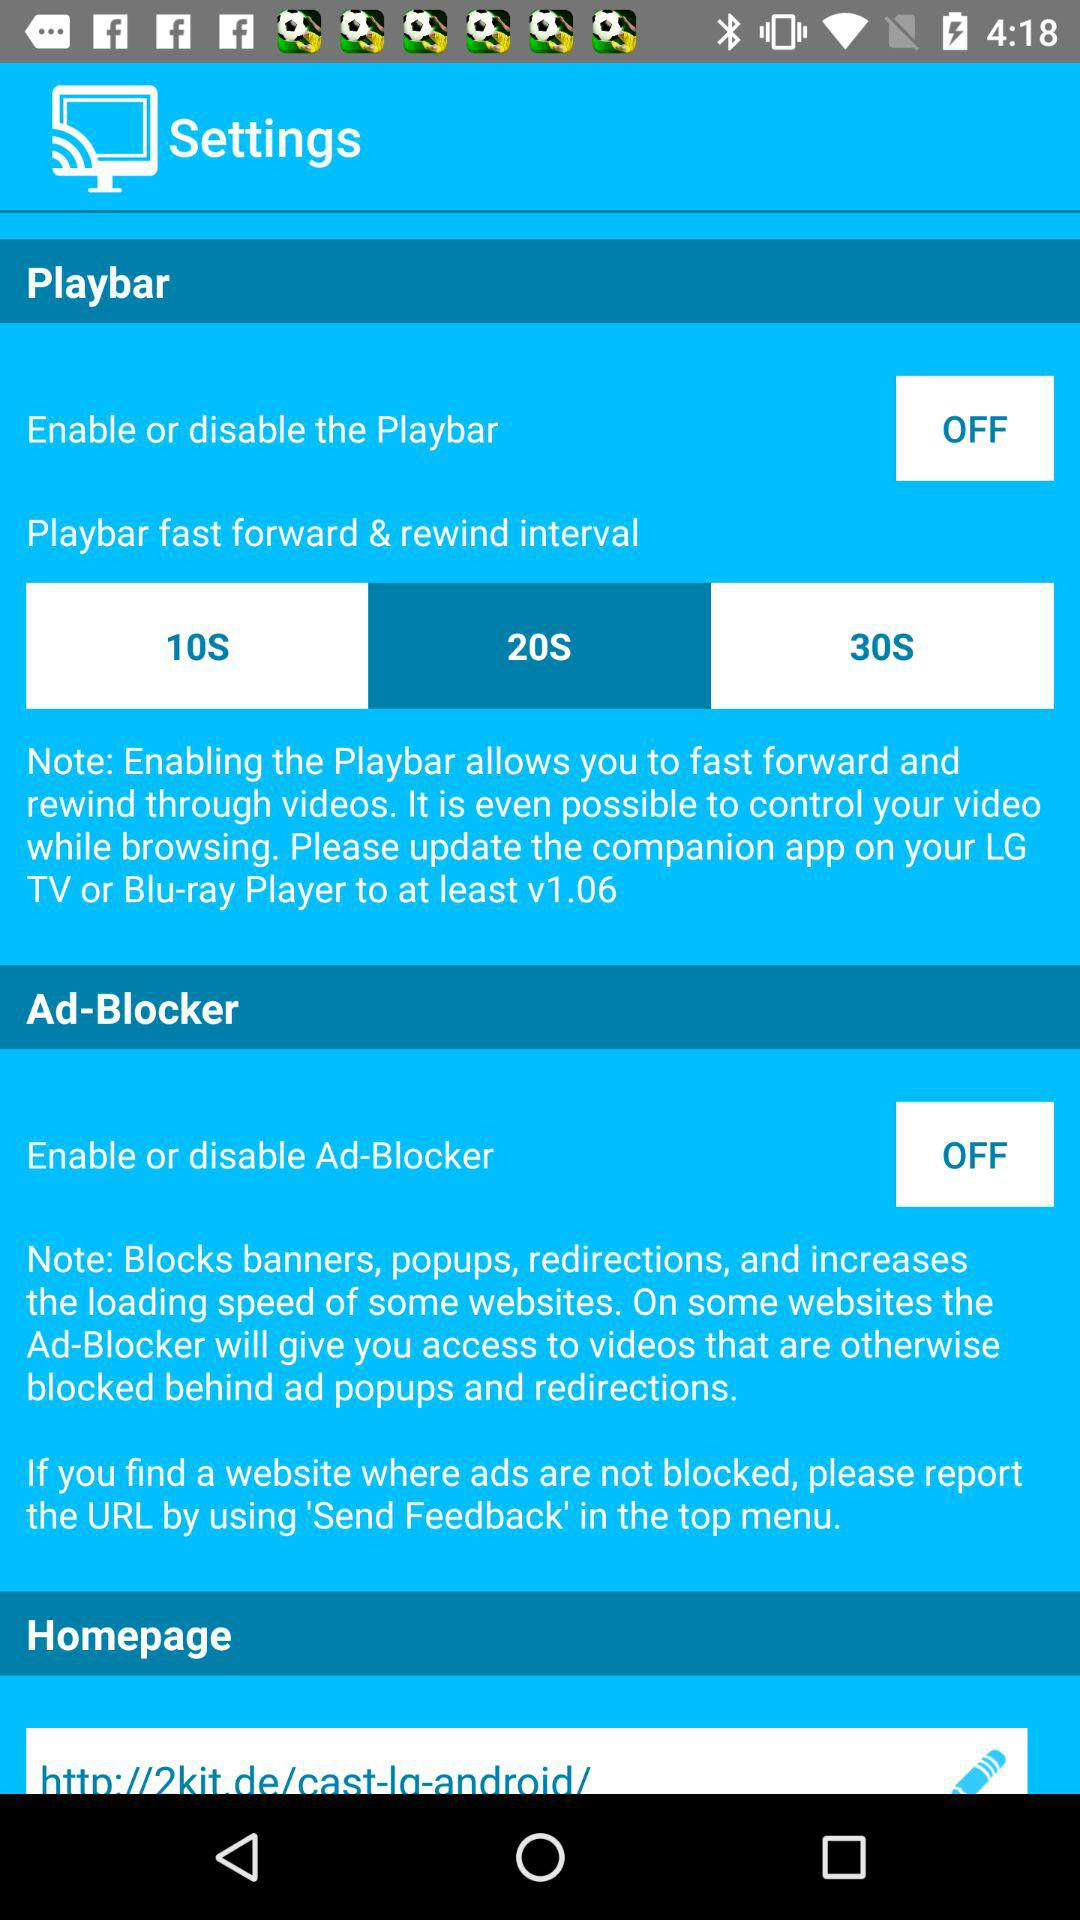Is "Homepage" checked or unchecked?
When the provided information is insufficient, respond with <no answer>. <no answer> 